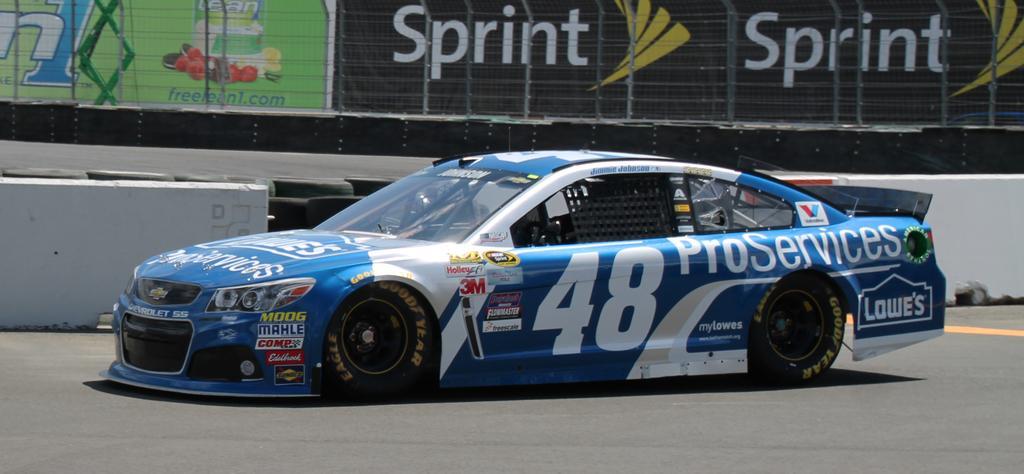In one or two sentences, can you explain what this image depicts? In this image we can see a car with the text and also numbers. We can also see the road, barrier, fence and behind the fence we can see the text boards. 